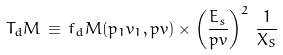<formula> <loc_0><loc_0><loc_500><loc_500>T _ { d } M \, \equiv \, f _ { d } M ( p _ { 1 } v _ { 1 } , p v ) \times \left ( \frac { E _ { s } } { p v } \right ) ^ { 2 } \, \frac { 1 } { X _ { S } }</formula> 